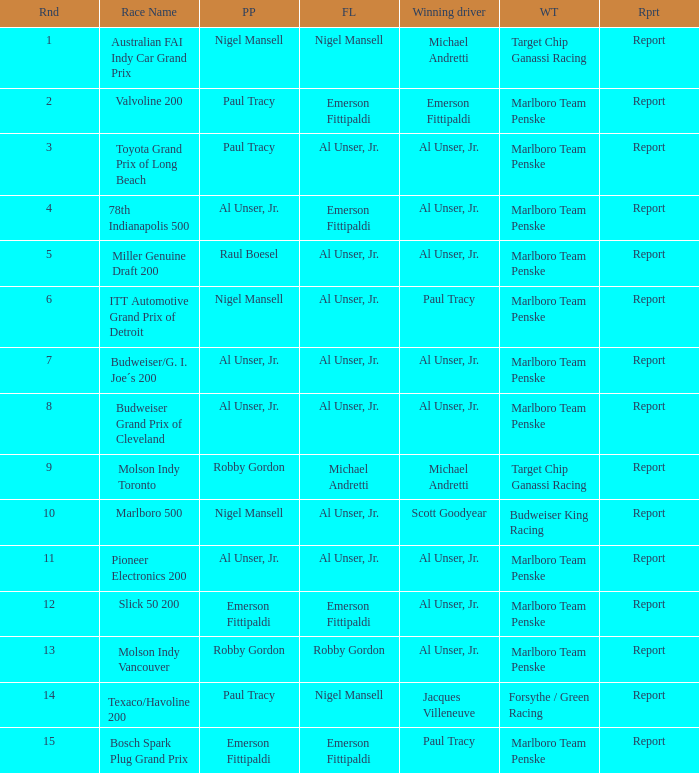Who was on the pole position in the Texaco/Havoline 200 race? Paul Tracy. 